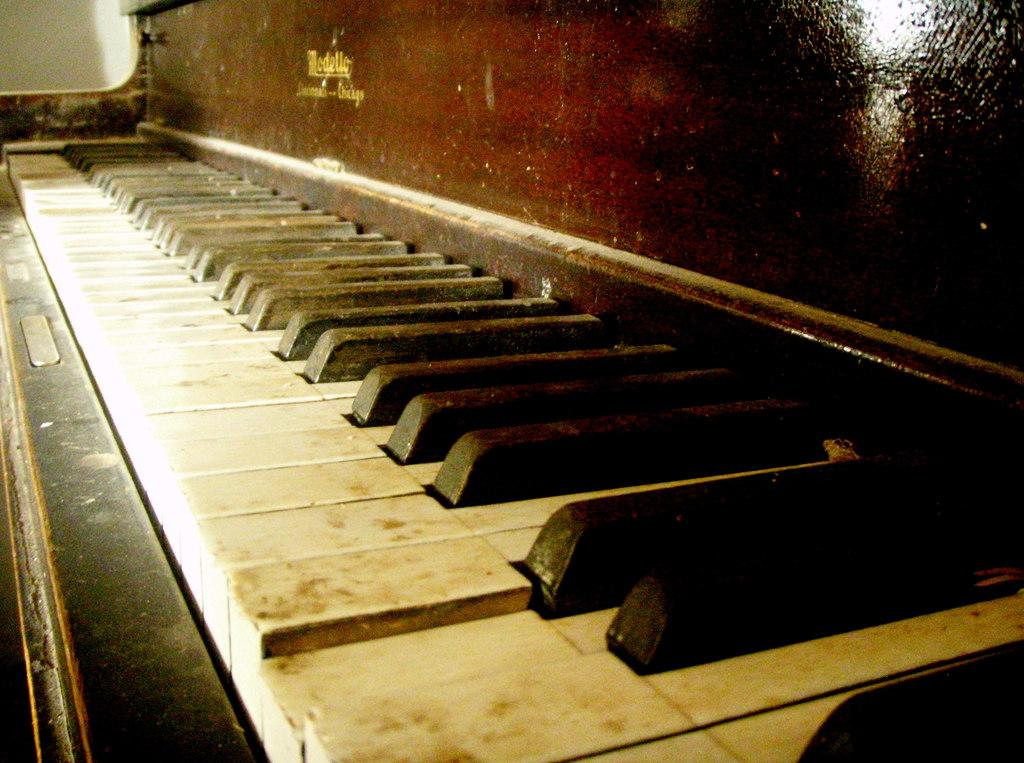What musical instrument is present in the image? There is a piano in the image. What type of instrument is the piano? The piano is a keyboard instrument. What might someone be doing with the piano in the image? Someone might be playing the piano or preparing to play it. What type of fruit is hanging from the piano in the image? There is no fruit present in the image, and therefore no fruit is hanging from the piano. 